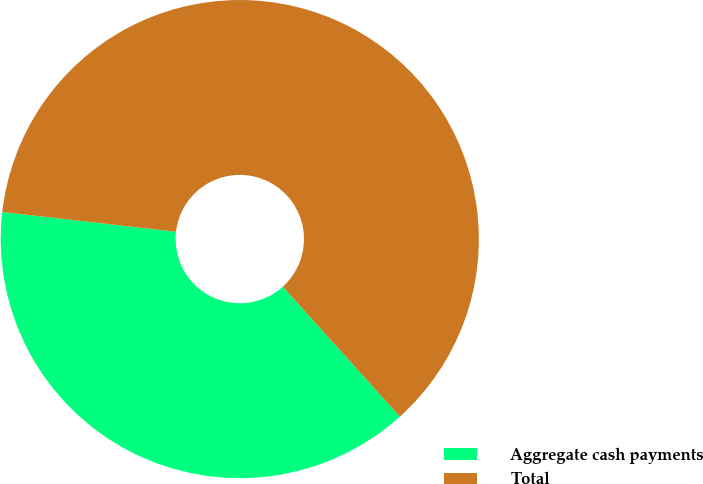Convert chart to OTSL. <chart><loc_0><loc_0><loc_500><loc_500><pie_chart><fcel>Aggregate cash payments<fcel>Total<nl><fcel>38.49%<fcel>61.51%<nl></chart> 